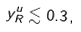<formula> <loc_0><loc_0><loc_500><loc_500>y _ { R } ^ { u } \lesssim 0 . 3 \, ,</formula> 